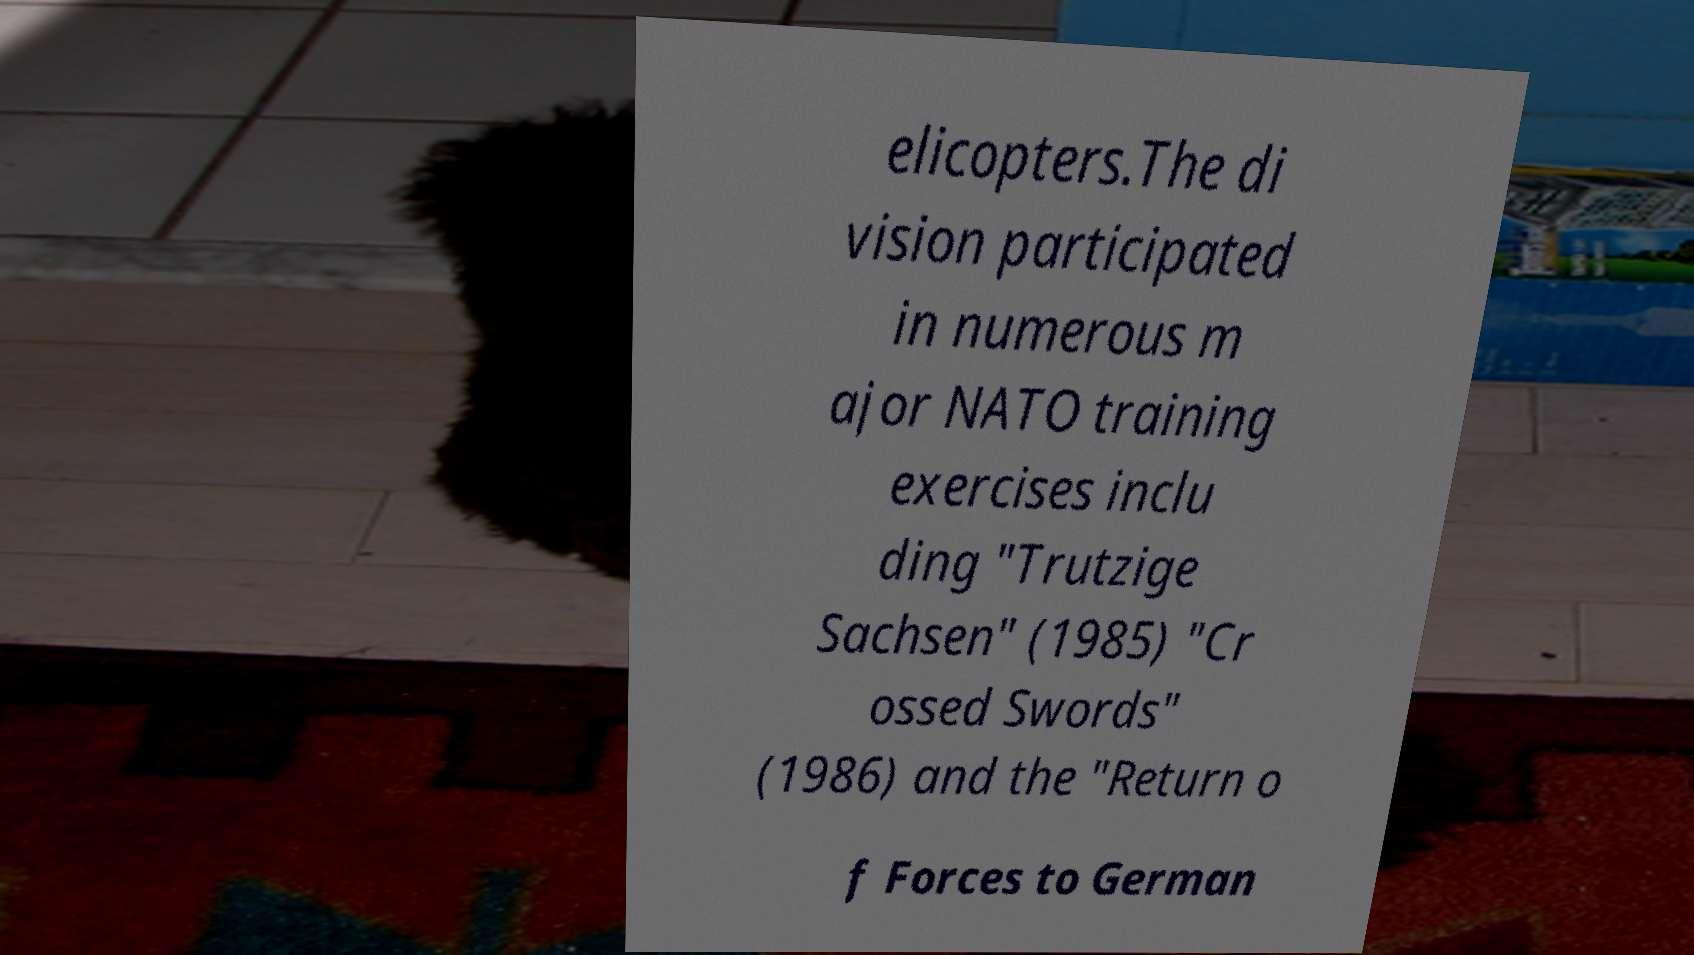For documentation purposes, I need the text within this image transcribed. Could you provide that? elicopters.The di vision participated in numerous m ajor NATO training exercises inclu ding "Trutzige Sachsen" (1985) "Cr ossed Swords" (1986) and the "Return o f Forces to German 